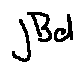Convert formula to latex. <formula><loc_0><loc_0><loc_500><loc_500>j B d</formula> 